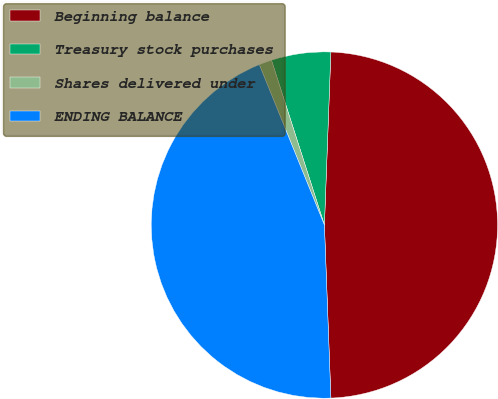<chart> <loc_0><loc_0><loc_500><loc_500><pie_chart><fcel>Beginning balance<fcel>Treasury stock purchases<fcel>Shares delivered under<fcel>ENDING BALANCE<nl><fcel>48.81%<fcel>5.54%<fcel>1.19%<fcel>44.46%<nl></chart> 